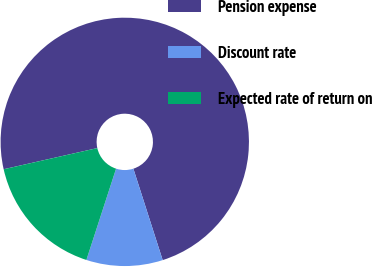<chart> <loc_0><loc_0><loc_500><loc_500><pie_chart><fcel>Pension expense<fcel>Discount rate<fcel>Expected rate of return on<nl><fcel>73.6%<fcel>9.94%<fcel>16.46%<nl></chart> 